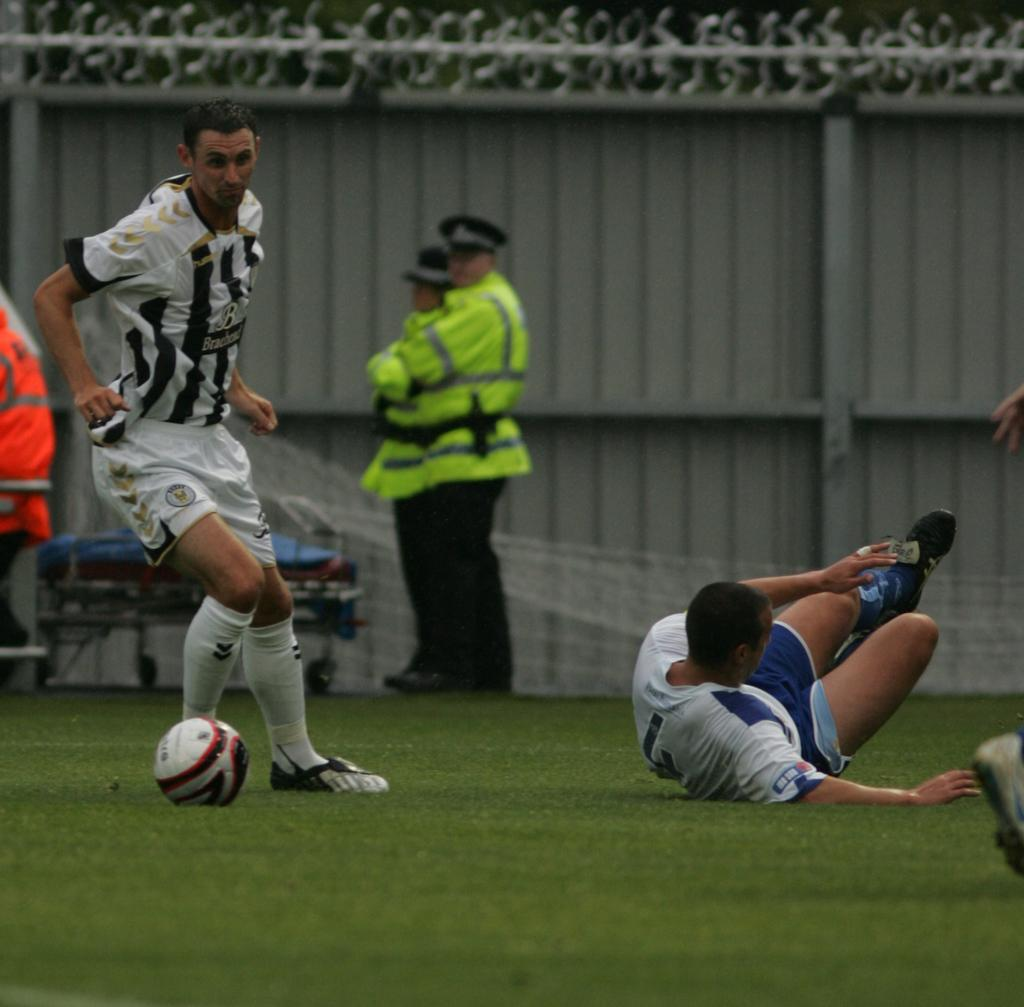How many people are in the image? There are persons in the image, but the exact number is not specified. What are the persons in the image doing? The persons are on the ground, and one of them is playing with a ball. What is the surface they are standing on? The ground is covered with grass. What type of yam is being used as a prop in the image? There is no yam present in the image. How does the cloud in the image affect the persons' activities? There is no cloud mentioned in the image, so it cannot affect the persons' activities. 